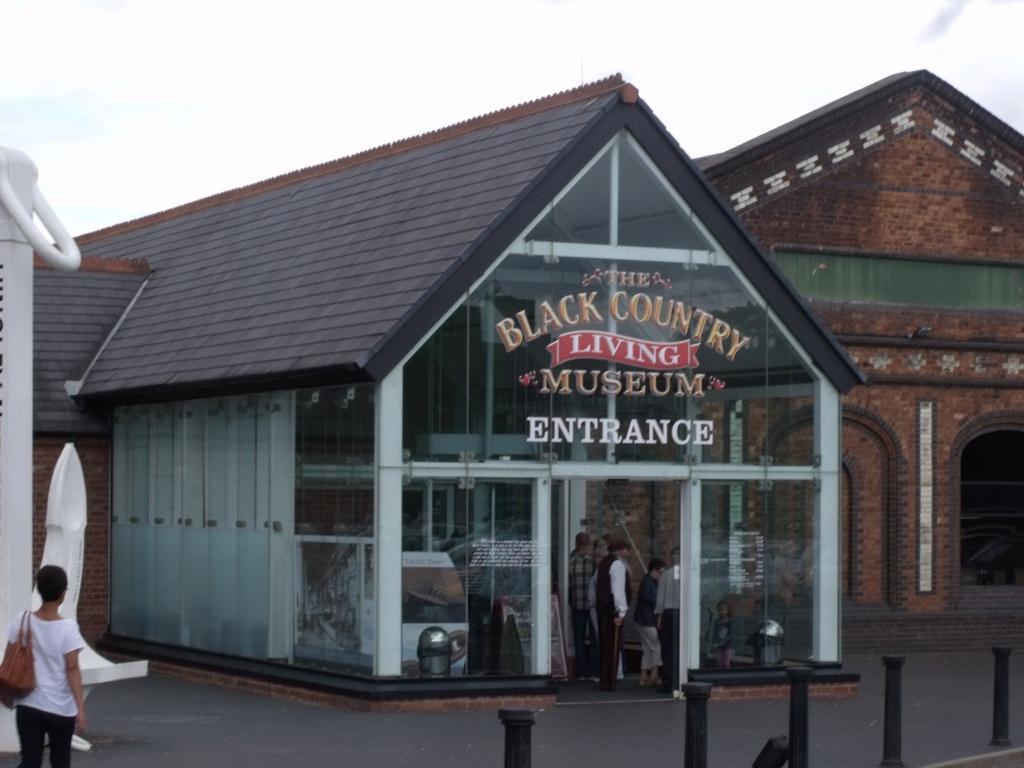Please provide a concise description of this image. In this image I can see a person standing wearing white shirt, black pant, brown color bag. Background I can see building in brown color. I can also see a glass door and sky is in white color. 